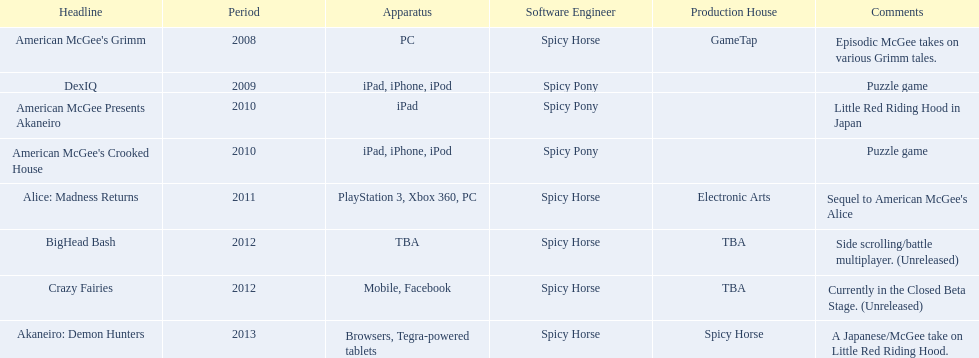What are all the titles? American McGee's Grimm, DexIQ, American McGee Presents Akaneiro, American McGee's Crooked House, Alice: Madness Returns, BigHead Bash, Crazy Fairies, Akaneiro: Demon Hunters. What platforms were they available on? PC, iPad, iPhone, iPod, iPad, iPad, iPhone, iPod, PlayStation 3, Xbox 360, PC, TBA, Mobile, Facebook, Browsers, Tegra-powered tablets. And which were available only on the ipad? American McGee Presents Akaneiro. 